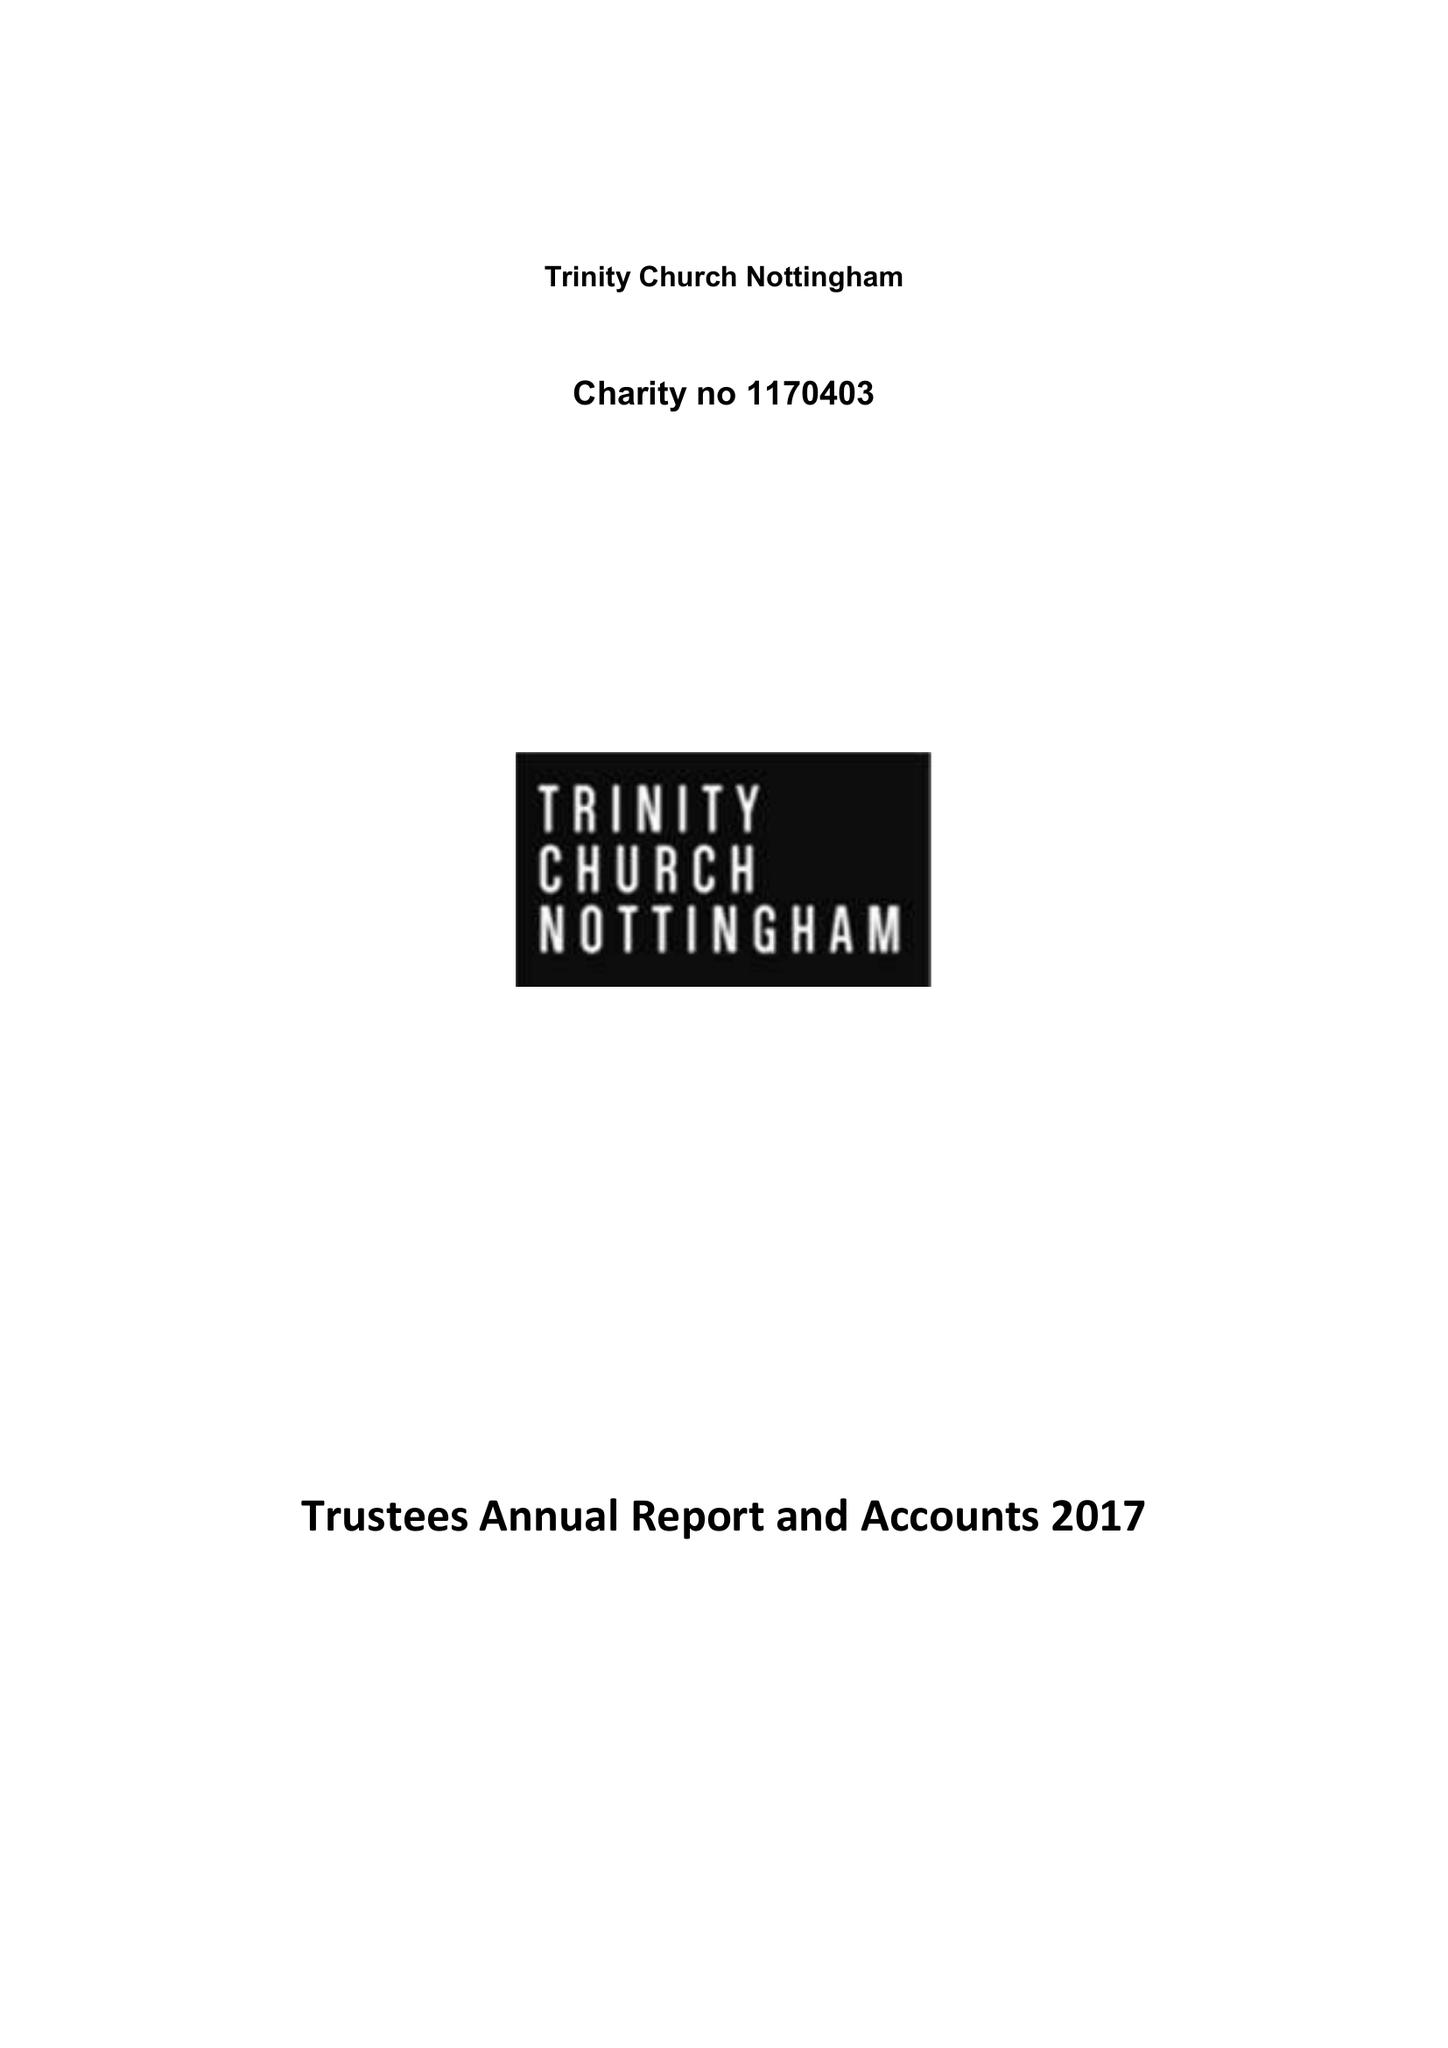What is the value for the charity_name?
Answer the question using a single word or phrase. Trinity Church Nottingham 